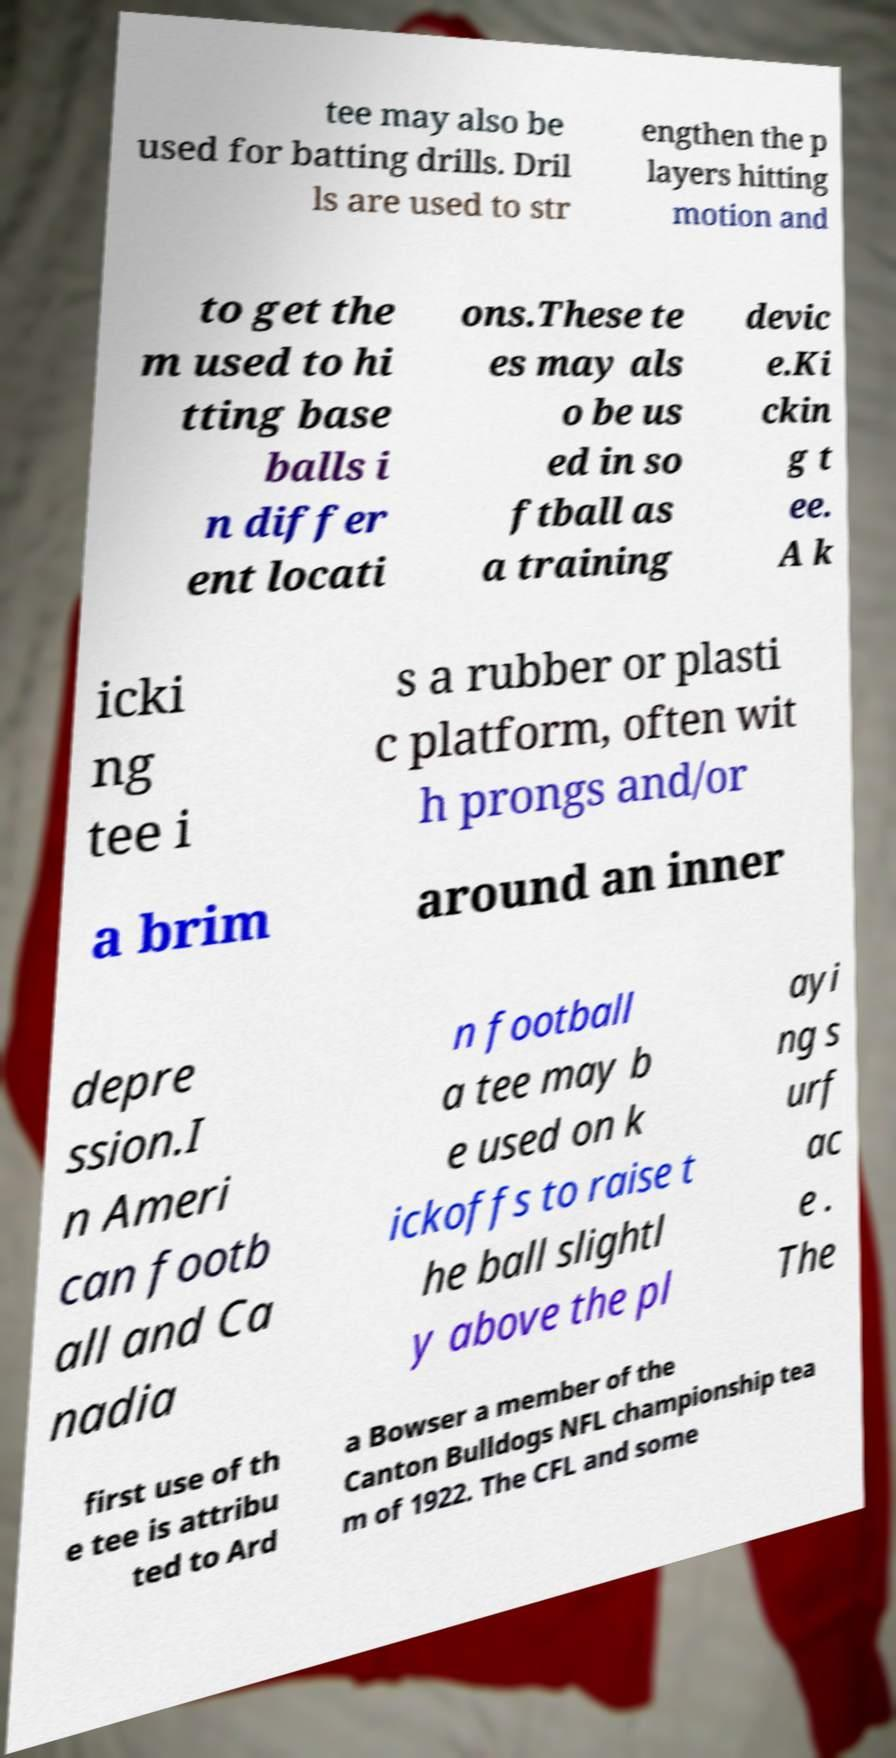I need the written content from this picture converted into text. Can you do that? tee may also be used for batting drills. Dril ls are used to str engthen the p layers hitting motion and to get the m used to hi tting base balls i n differ ent locati ons.These te es may als o be us ed in so ftball as a training devic e.Ki ckin g t ee. A k icki ng tee i s a rubber or plasti c platform, often wit h prongs and/or a brim around an inner depre ssion.I n Ameri can footb all and Ca nadia n football a tee may b e used on k ickoffs to raise t he ball slightl y above the pl ayi ng s urf ac e . The first use of th e tee is attribu ted to Ard a Bowser a member of the Canton Bulldogs NFL championship tea m of 1922. The CFL and some 